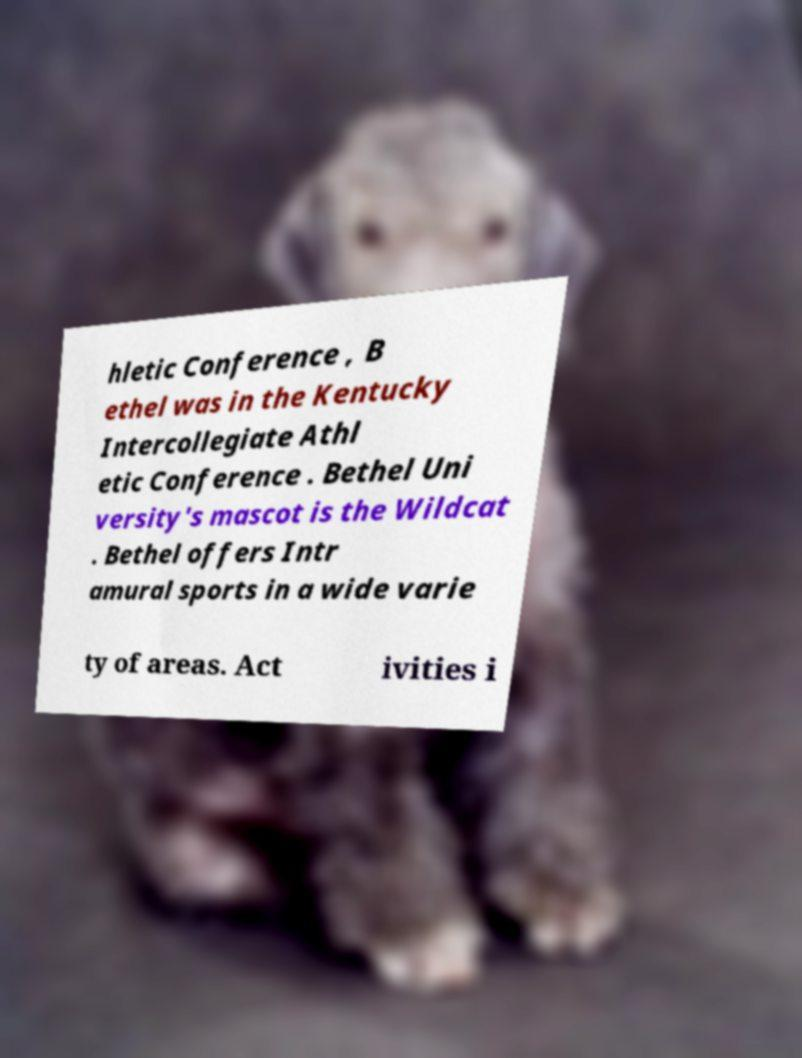There's text embedded in this image that I need extracted. Can you transcribe it verbatim? hletic Conference , B ethel was in the Kentucky Intercollegiate Athl etic Conference . Bethel Uni versity's mascot is the Wildcat . Bethel offers Intr amural sports in a wide varie ty of areas. Act ivities i 